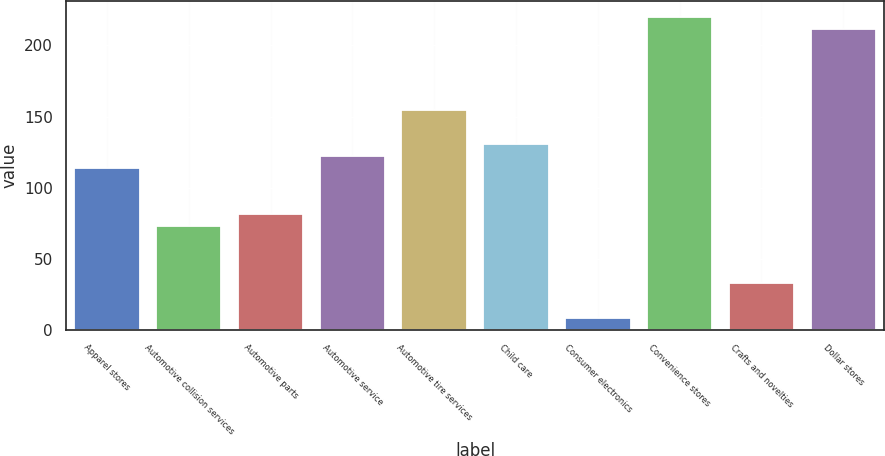Convert chart to OTSL. <chart><loc_0><loc_0><loc_500><loc_500><bar_chart><fcel>Apparel stores<fcel>Automotive collision services<fcel>Automotive parts<fcel>Automotive service<fcel>Automotive tire services<fcel>Child care<fcel>Consumer electronics<fcel>Convenience stores<fcel>Crafts and novelties<fcel>Dollar stores<nl><fcel>114.06<fcel>73.36<fcel>81.5<fcel>122.2<fcel>154.76<fcel>130.34<fcel>8.24<fcel>219.88<fcel>32.66<fcel>211.74<nl></chart> 